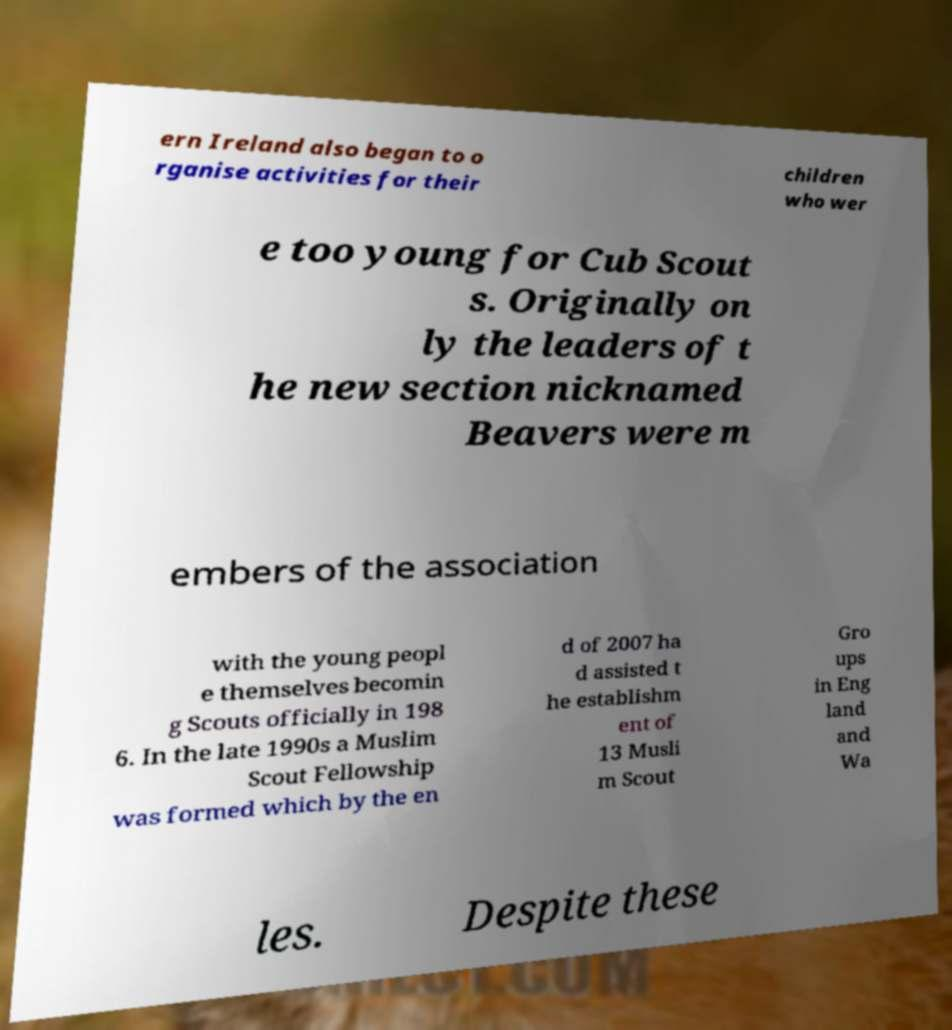Please identify and transcribe the text found in this image. ern Ireland also began to o rganise activities for their children who wer e too young for Cub Scout s. Originally on ly the leaders of t he new section nicknamed Beavers were m embers of the association with the young peopl e themselves becomin g Scouts officially in 198 6. In the late 1990s a Muslim Scout Fellowship was formed which by the en d of 2007 ha d assisted t he establishm ent of 13 Musli m Scout Gro ups in Eng land and Wa les. Despite these 